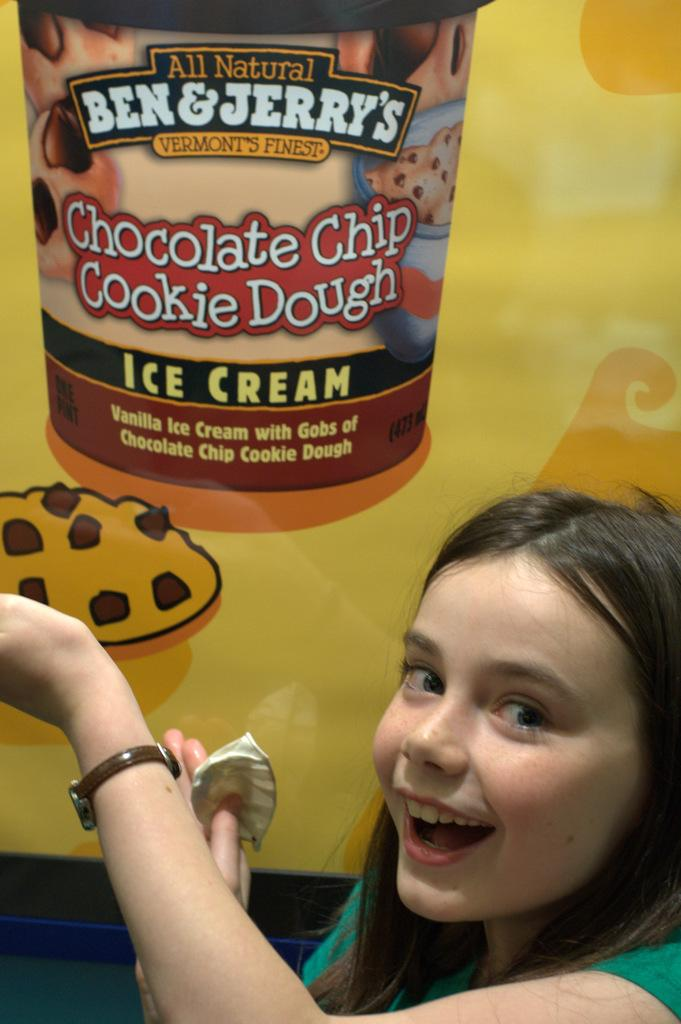Who is present in the image? There is a woman in the image. What accessory is the woman wearing? The woman is wearing a watch. What can be seen on the poster in the image? There is a poster of a box in the image. What type of pipe is visible in the image? There is no pipe present in the image. Is the woman opening a gate in the image? There is no gate present in the image. 